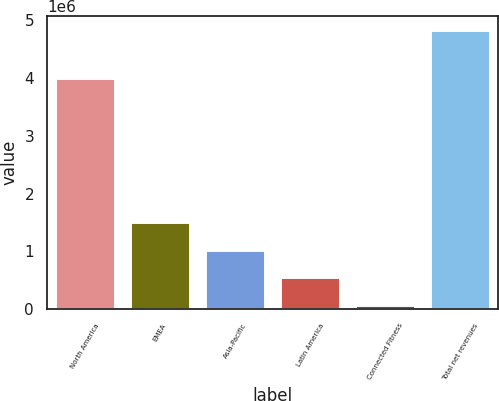<chart> <loc_0><loc_0><loc_500><loc_500><bar_chart><fcel>North America<fcel>EMEA<fcel>Asia-Pacific<fcel>Latin America<fcel>Connected Fitness<fcel>Total net revenues<nl><fcel>4.00531e+06<fcel>1.50391e+06<fcel>1.02942e+06<fcel>554936<fcel>80447<fcel>4.82534e+06<nl></chart> 